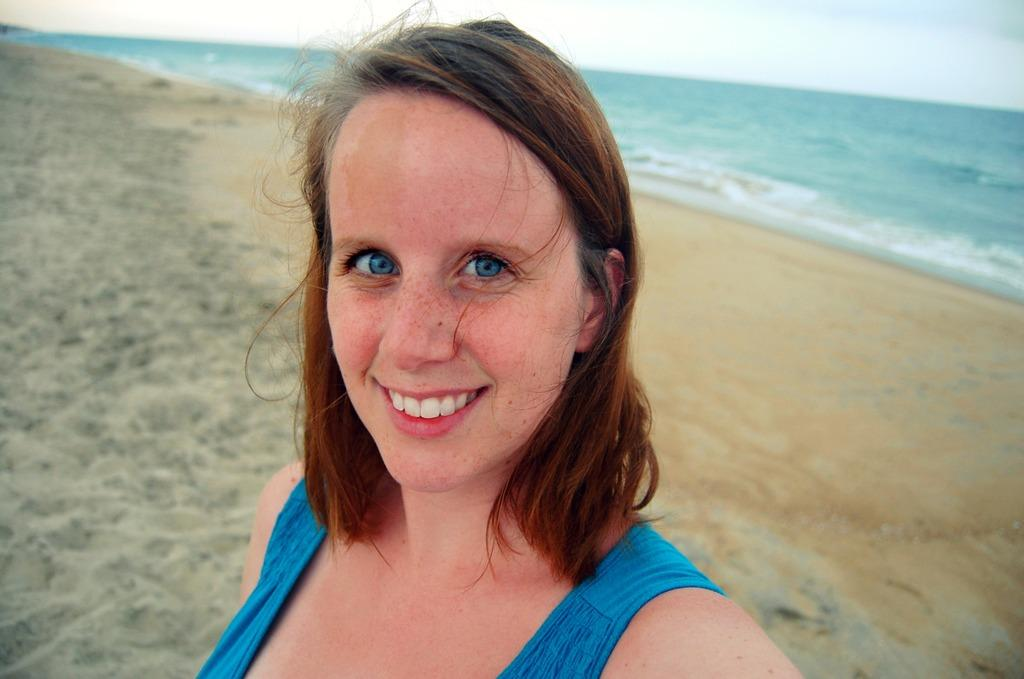Who is present in the image? There is a lady in the image. What is the lady doing in the image? The lady is smiling in the image. What type of environment is depicted in the image? There is sand, water, and sky visible in the image, suggesting a beach or coastal setting. How many matches are being used by the lady in the image? There are no matches present in the image. What type of pizzas can be seen on the sand in the image? There are no pizzas present in the image. 